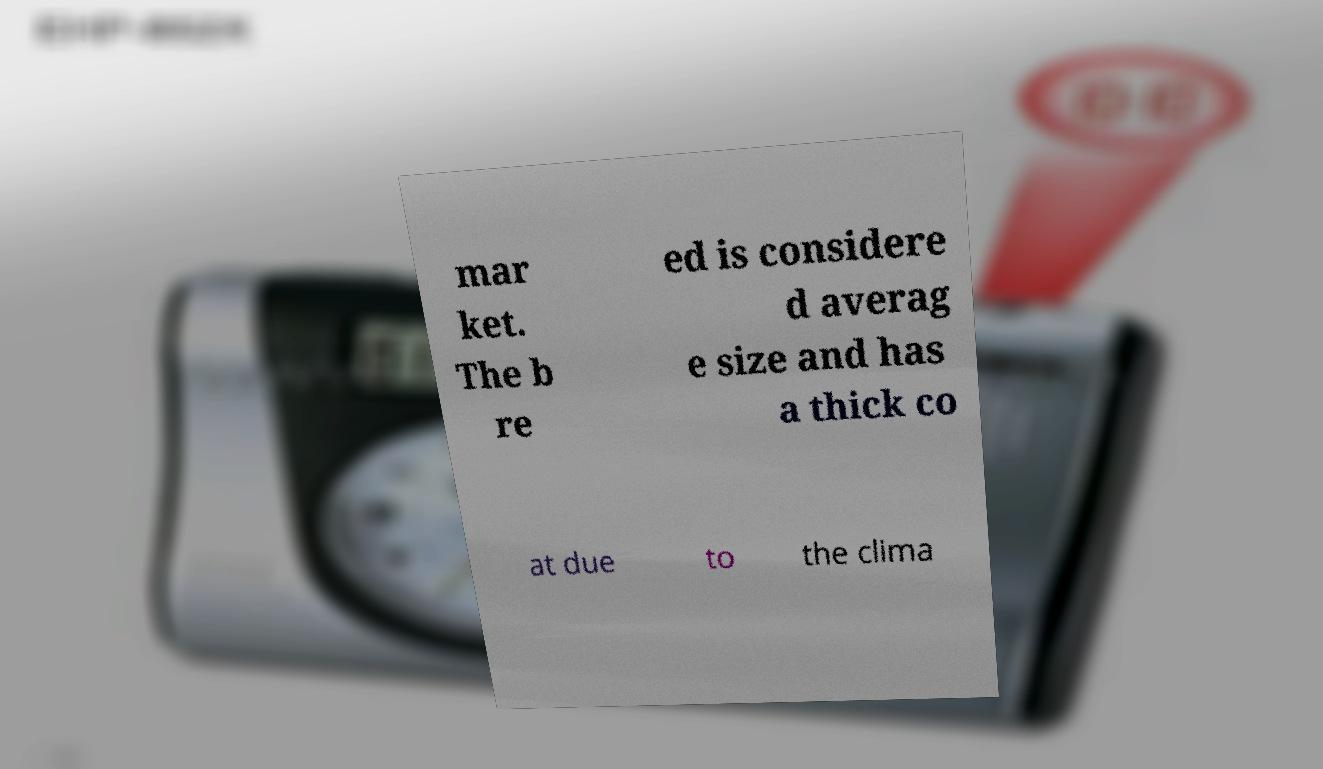There's text embedded in this image that I need extracted. Can you transcribe it verbatim? mar ket. The b re ed is considere d averag e size and has a thick co at due to the clima 